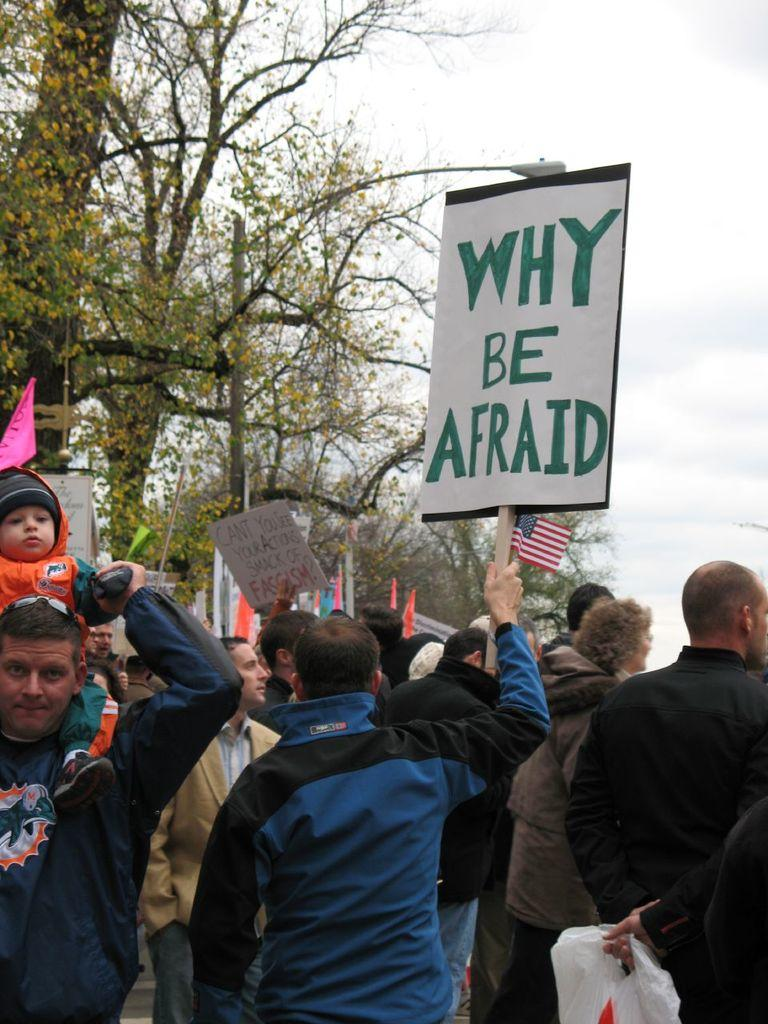<image>
Give a short and clear explanation of the subsequent image. A protest is going on and the people are asking why be afraid. 